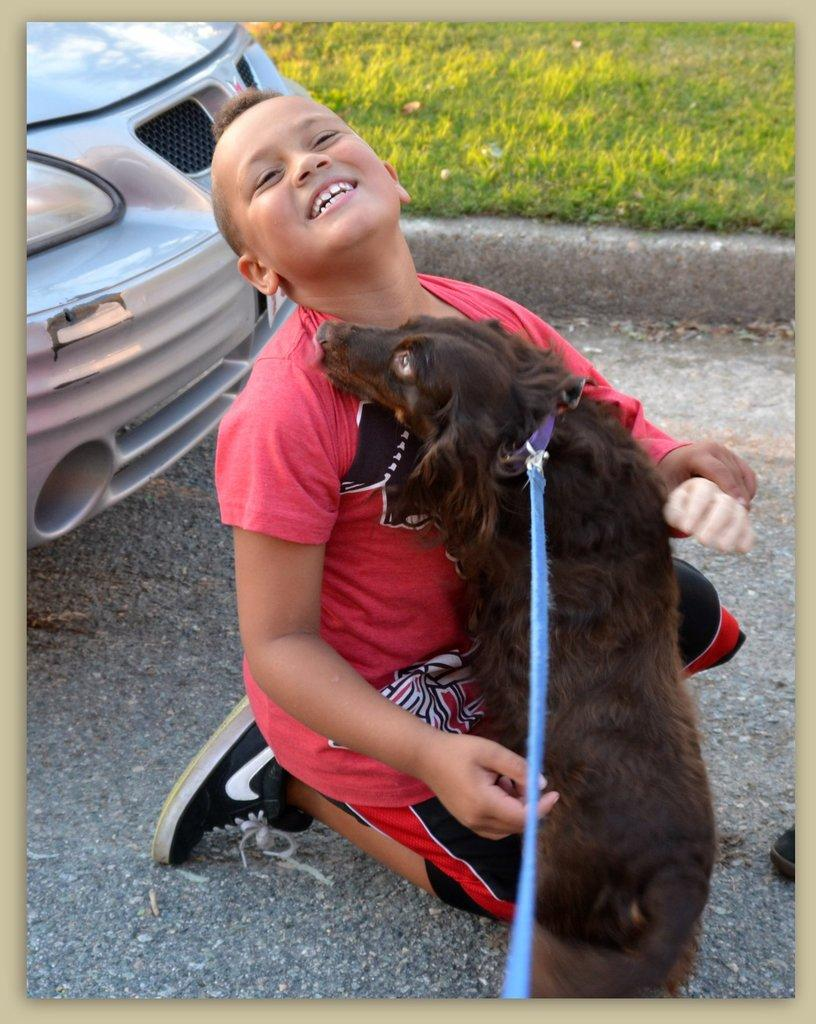What is the boy doing in the image? The boy is sitting on his knees in the image. What is near the boy? A dog is close to the boy. What can be seen on the left side of the image? There is a car on the left side of the image. What type of surface is visible behind the boy and the dog? There is grass visible behind the boy and the dog. What is the boy's expression in the image? The boy is smiling in the image. What type of letters is the band playing in the image? There is no band or letters present in the image. What is the color of the copper object in the image? There is no copper object present in the image. 